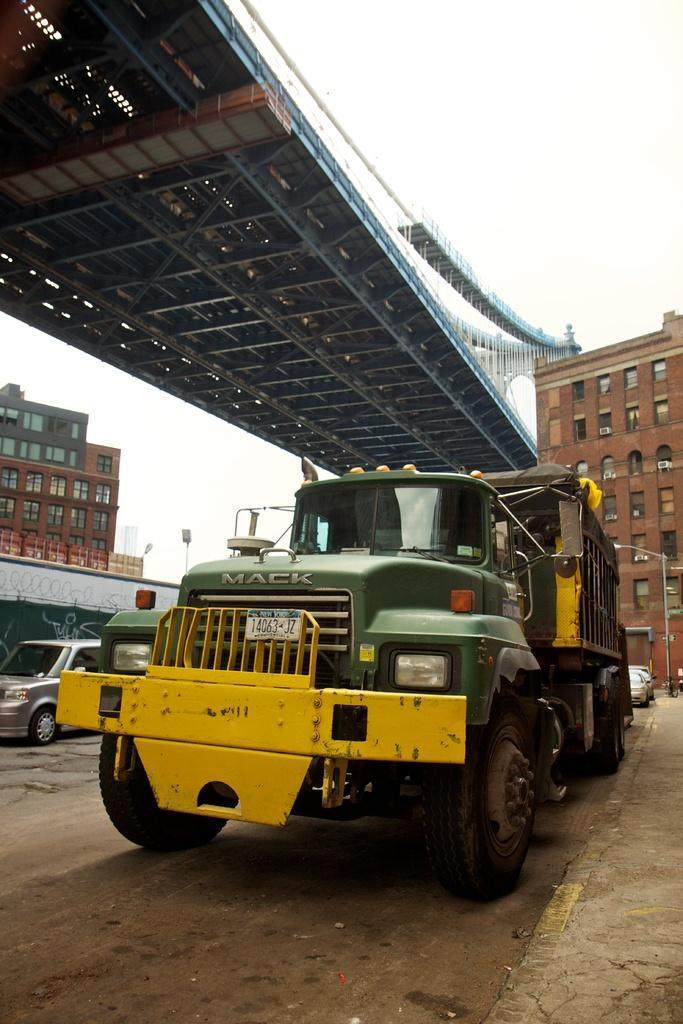Provide a one-sentence caption for the provided image. Green and yellow truck with the plate "14063JZ" in front of a building. 